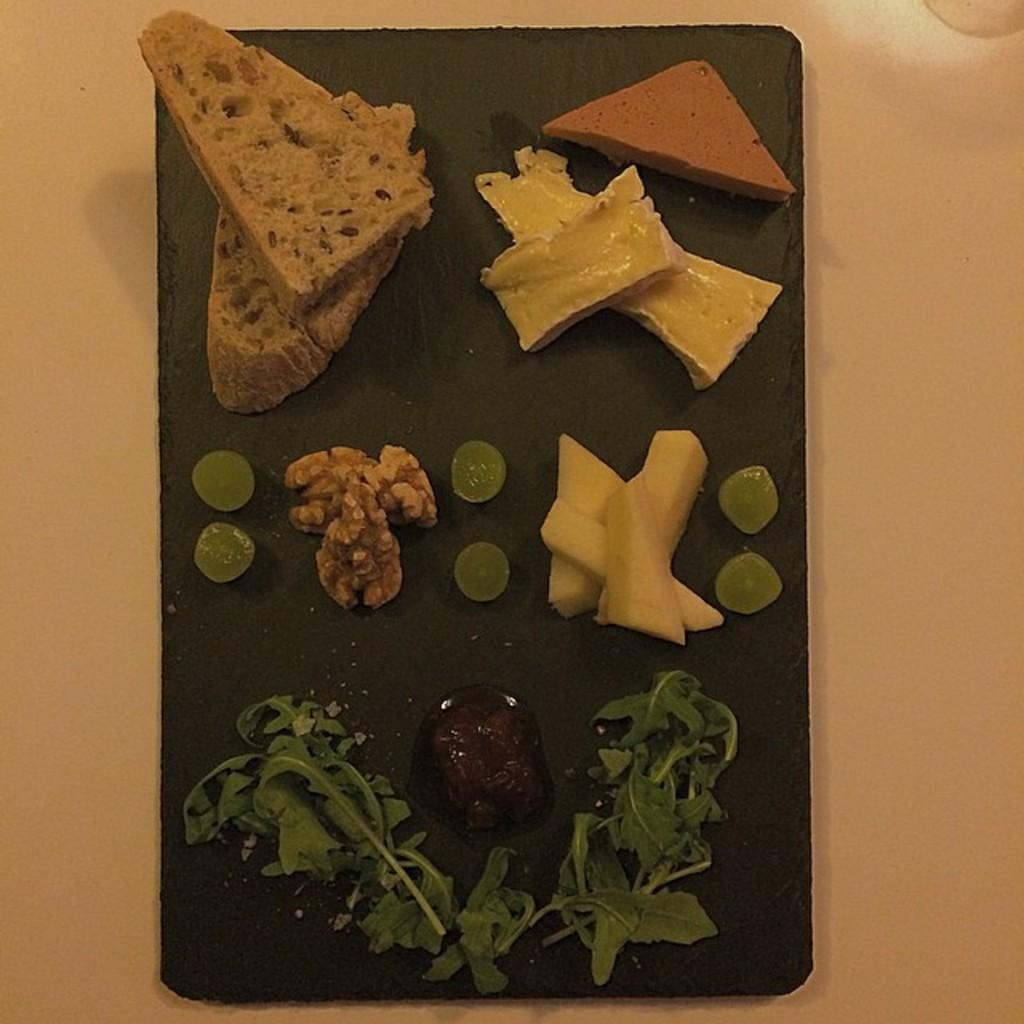What types of food items can be seen in the image? There are food items, walnuts, and leafy vegetables visible in the image. Where are the food items, walnuts, and leafy vegetables located? They are on a plate in the image. What is the plate placed on in the image? The plate is on a table. Can you tell me how many mint leaves are on the plate in the image? There is no mention of mint leaves in the image; only food items, walnuts, and leafy vegetables are present. 